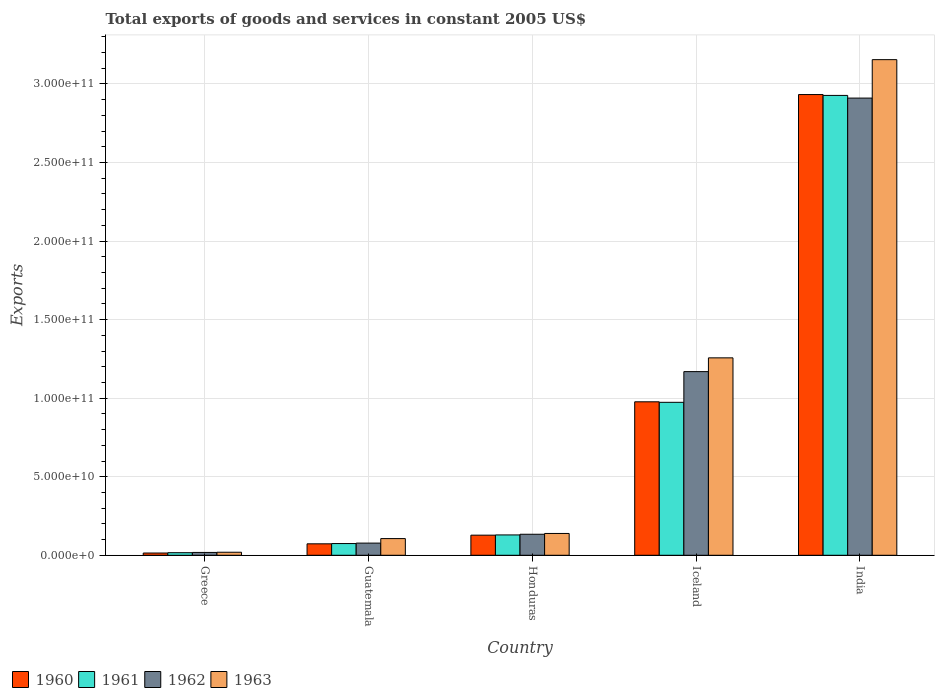How many different coloured bars are there?
Give a very brief answer. 4. Are the number of bars on each tick of the X-axis equal?
Provide a short and direct response. Yes. How many bars are there on the 1st tick from the left?
Offer a very short reply. 4. How many bars are there on the 4th tick from the right?
Keep it short and to the point. 4. What is the total exports of goods and services in 1960 in Greece?
Offer a terse response. 1.43e+09. Across all countries, what is the maximum total exports of goods and services in 1960?
Make the answer very short. 2.93e+11. Across all countries, what is the minimum total exports of goods and services in 1963?
Provide a short and direct response. 1.93e+09. In which country was the total exports of goods and services in 1962 maximum?
Make the answer very short. India. What is the total total exports of goods and services in 1960 in the graph?
Your response must be concise. 4.12e+11. What is the difference between the total exports of goods and services in 1961 in Guatemala and that in Honduras?
Your answer should be very brief. -5.49e+09. What is the difference between the total exports of goods and services in 1963 in Greece and the total exports of goods and services in 1960 in Honduras?
Offer a very short reply. -1.09e+1. What is the average total exports of goods and services in 1963 per country?
Keep it short and to the point. 9.35e+1. What is the difference between the total exports of goods and services of/in 1963 and total exports of goods and services of/in 1961 in Honduras?
Provide a short and direct response. 9.34e+08. In how many countries, is the total exports of goods and services in 1962 greater than 70000000000 US$?
Your response must be concise. 2. What is the ratio of the total exports of goods and services in 1961 in Honduras to that in Iceland?
Offer a very short reply. 0.13. Is the total exports of goods and services in 1961 in Greece less than that in India?
Your answer should be compact. Yes. Is the difference between the total exports of goods and services in 1963 in Greece and India greater than the difference between the total exports of goods and services in 1961 in Greece and India?
Keep it short and to the point. No. What is the difference between the highest and the second highest total exports of goods and services in 1961?
Offer a terse response. 2.80e+11. What is the difference between the highest and the lowest total exports of goods and services in 1961?
Make the answer very short. 2.91e+11. Is the sum of the total exports of goods and services in 1963 in Iceland and India greater than the maximum total exports of goods and services in 1962 across all countries?
Make the answer very short. Yes. Is it the case that in every country, the sum of the total exports of goods and services in 1961 and total exports of goods and services in 1963 is greater than the sum of total exports of goods and services in 1960 and total exports of goods and services in 1962?
Ensure brevity in your answer.  No. What does the 1st bar from the left in Iceland represents?
Provide a short and direct response. 1960. What does the 4th bar from the right in Guatemala represents?
Your answer should be very brief. 1960. Is it the case that in every country, the sum of the total exports of goods and services in 1963 and total exports of goods and services in 1960 is greater than the total exports of goods and services in 1961?
Your answer should be very brief. Yes. How many bars are there?
Keep it short and to the point. 20. How many countries are there in the graph?
Give a very brief answer. 5. Does the graph contain any zero values?
Make the answer very short. No. Where does the legend appear in the graph?
Provide a short and direct response. Bottom left. How many legend labels are there?
Offer a very short reply. 4. How are the legend labels stacked?
Provide a succinct answer. Horizontal. What is the title of the graph?
Provide a short and direct response. Total exports of goods and services in constant 2005 US$. Does "2013" appear as one of the legend labels in the graph?
Your answer should be very brief. No. What is the label or title of the X-axis?
Make the answer very short. Country. What is the label or title of the Y-axis?
Keep it short and to the point. Exports. What is the Exports of 1960 in Greece?
Offer a very short reply. 1.43e+09. What is the Exports in 1961 in Greece?
Your answer should be very brief. 1.64e+09. What is the Exports of 1962 in Greece?
Your answer should be compact. 1.81e+09. What is the Exports in 1963 in Greece?
Provide a short and direct response. 1.93e+09. What is the Exports of 1960 in Guatemala?
Make the answer very short. 7.29e+09. What is the Exports in 1961 in Guatemala?
Keep it short and to the point. 7.46e+09. What is the Exports in 1962 in Guatemala?
Provide a short and direct response. 7.75e+09. What is the Exports in 1963 in Guatemala?
Ensure brevity in your answer.  1.06e+1. What is the Exports in 1960 in Honduras?
Keep it short and to the point. 1.28e+1. What is the Exports in 1961 in Honduras?
Offer a terse response. 1.30e+1. What is the Exports of 1962 in Honduras?
Your answer should be compact. 1.34e+1. What is the Exports of 1963 in Honduras?
Ensure brevity in your answer.  1.39e+1. What is the Exports of 1960 in Iceland?
Give a very brief answer. 9.77e+1. What is the Exports in 1961 in Iceland?
Offer a terse response. 9.74e+1. What is the Exports in 1962 in Iceland?
Provide a short and direct response. 1.17e+11. What is the Exports in 1963 in Iceland?
Give a very brief answer. 1.26e+11. What is the Exports of 1960 in India?
Ensure brevity in your answer.  2.93e+11. What is the Exports in 1961 in India?
Offer a very short reply. 2.93e+11. What is the Exports in 1962 in India?
Your answer should be compact. 2.91e+11. What is the Exports in 1963 in India?
Keep it short and to the point. 3.15e+11. Across all countries, what is the maximum Exports of 1960?
Make the answer very short. 2.93e+11. Across all countries, what is the maximum Exports in 1961?
Ensure brevity in your answer.  2.93e+11. Across all countries, what is the maximum Exports in 1962?
Keep it short and to the point. 2.91e+11. Across all countries, what is the maximum Exports in 1963?
Your answer should be very brief. 3.15e+11. Across all countries, what is the minimum Exports in 1960?
Your answer should be very brief. 1.43e+09. Across all countries, what is the minimum Exports of 1961?
Offer a very short reply. 1.64e+09. Across all countries, what is the minimum Exports in 1962?
Give a very brief answer. 1.81e+09. Across all countries, what is the minimum Exports of 1963?
Offer a very short reply. 1.93e+09. What is the total Exports of 1960 in the graph?
Your answer should be compact. 4.12e+11. What is the total Exports in 1961 in the graph?
Ensure brevity in your answer.  4.12e+11. What is the total Exports of 1962 in the graph?
Provide a short and direct response. 4.31e+11. What is the total Exports in 1963 in the graph?
Give a very brief answer. 4.68e+11. What is the difference between the Exports in 1960 in Greece and that in Guatemala?
Your response must be concise. -5.85e+09. What is the difference between the Exports in 1961 in Greece and that in Guatemala?
Your answer should be very brief. -5.82e+09. What is the difference between the Exports in 1962 in Greece and that in Guatemala?
Provide a succinct answer. -5.94e+09. What is the difference between the Exports of 1963 in Greece and that in Guatemala?
Give a very brief answer. -8.70e+09. What is the difference between the Exports of 1960 in Greece and that in Honduras?
Provide a short and direct response. -1.14e+1. What is the difference between the Exports in 1961 in Greece and that in Honduras?
Offer a very short reply. -1.13e+1. What is the difference between the Exports in 1962 in Greece and that in Honduras?
Ensure brevity in your answer.  -1.16e+1. What is the difference between the Exports of 1963 in Greece and that in Honduras?
Your answer should be compact. -1.20e+1. What is the difference between the Exports in 1960 in Greece and that in Iceland?
Offer a very short reply. -9.63e+1. What is the difference between the Exports in 1961 in Greece and that in Iceland?
Your answer should be compact. -9.57e+1. What is the difference between the Exports of 1962 in Greece and that in Iceland?
Provide a short and direct response. -1.15e+11. What is the difference between the Exports in 1963 in Greece and that in Iceland?
Offer a terse response. -1.24e+11. What is the difference between the Exports of 1960 in Greece and that in India?
Keep it short and to the point. -2.92e+11. What is the difference between the Exports in 1961 in Greece and that in India?
Provide a succinct answer. -2.91e+11. What is the difference between the Exports in 1962 in Greece and that in India?
Give a very brief answer. -2.89e+11. What is the difference between the Exports of 1963 in Greece and that in India?
Provide a short and direct response. -3.14e+11. What is the difference between the Exports of 1960 in Guatemala and that in Honduras?
Provide a short and direct response. -5.51e+09. What is the difference between the Exports of 1961 in Guatemala and that in Honduras?
Your answer should be very brief. -5.49e+09. What is the difference between the Exports in 1962 in Guatemala and that in Honduras?
Your answer should be compact. -5.63e+09. What is the difference between the Exports in 1963 in Guatemala and that in Honduras?
Your answer should be compact. -3.26e+09. What is the difference between the Exports of 1960 in Guatemala and that in Iceland?
Your answer should be very brief. -9.04e+1. What is the difference between the Exports of 1961 in Guatemala and that in Iceland?
Offer a very short reply. -8.99e+1. What is the difference between the Exports in 1962 in Guatemala and that in Iceland?
Your answer should be very brief. -1.09e+11. What is the difference between the Exports of 1963 in Guatemala and that in Iceland?
Your answer should be compact. -1.15e+11. What is the difference between the Exports of 1960 in Guatemala and that in India?
Provide a succinct answer. -2.86e+11. What is the difference between the Exports of 1961 in Guatemala and that in India?
Provide a short and direct response. -2.85e+11. What is the difference between the Exports in 1962 in Guatemala and that in India?
Provide a short and direct response. -2.83e+11. What is the difference between the Exports of 1963 in Guatemala and that in India?
Provide a succinct answer. -3.05e+11. What is the difference between the Exports of 1960 in Honduras and that in Iceland?
Provide a short and direct response. -8.49e+1. What is the difference between the Exports in 1961 in Honduras and that in Iceland?
Make the answer very short. -8.44e+1. What is the difference between the Exports of 1962 in Honduras and that in Iceland?
Provide a succinct answer. -1.04e+11. What is the difference between the Exports in 1963 in Honduras and that in Iceland?
Your answer should be compact. -1.12e+11. What is the difference between the Exports in 1960 in Honduras and that in India?
Your response must be concise. -2.80e+11. What is the difference between the Exports of 1961 in Honduras and that in India?
Provide a succinct answer. -2.80e+11. What is the difference between the Exports of 1962 in Honduras and that in India?
Make the answer very short. -2.78e+11. What is the difference between the Exports of 1963 in Honduras and that in India?
Provide a succinct answer. -3.02e+11. What is the difference between the Exports of 1960 in Iceland and that in India?
Offer a terse response. -1.96e+11. What is the difference between the Exports in 1961 in Iceland and that in India?
Your answer should be compact. -1.95e+11. What is the difference between the Exports in 1962 in Iceland and that in India?
Provide a succinct answer. -1.74e+11. What is the difference between the Exports of 1963 in Iceland and that in India?
Your answer should be very brief. -1.90e+11. What is the difference between the Exports in 1960 in Greece and the Exports in 1961 in Guatemala?
Provide a succinct answer. -6.02e+09. What is the difference between the Exports of 1960 in Greece and the Exports of 1962 in Guatemala?
Make the answer very short. -6.31e+09. What is the difference between the Exports in 1960 in Greece and the Exports in 1963 in Guatemala?
Make the answer very short. -9.19e+09. What is the difference between the Exports of 1961 in Greece and the Exports of 1962 in Guatemala?
Your answer should be compact. -6.10e+09. What is the difference between the Exports of 1961 in Greece and the Exports of 1963 in Guatemala?
Your answer should be compact. -8.98e+09. What is the difference between the Exports of 1962 in Greece and the Exports of 1963 in Guatemala?
Your answer should be very brief. -8.82e+09. What is the difference between the Exports of 1960 in Greece and the Exports of 1961 in Honduras?
Your answer should be compact. -1.15e+1. What is the difference between the Exports in 1960 in Greece and the Exports in 1962 in Honduras?
Your response must be concise. -1.19e+1. What is the difference between the Exports in 1960 in Greece and the Exports in 1963 in Honduras?
Ensure brevity in your answer.  -1.25e+1. What is the difference between the Exports of 1961 in Greece and the Exports of 1962 in Honduras?
Provide a succinct answer. -1.17e+1. What is the difference between the Exports in 1961 in Greece and the Exports in 1963 in Honduras?
Offer a terse response. -1.22e+1. What is the difference between the Exports in 1962 in Greece and the Exports in 1963 in Honduras?
Offer a terse response. -1.21e+1. What is the difference between the Exports of 1960 in Greece and the Exports of 1961 in Iceland?
Give a very brief answer. -9.59e+1. What is the difference between the Exports of 1960 in Greece and the Exports of 1962 in Iceland?
Your response must be concise. -1.15e+11. What is the difference between the Exports in 1960 in Greece and the Exports in 1963 in Iceland?
Your answer should be very brief. -1.24e+11. What is the difference between the Exports in 1961 in Greece and the Exports in 1962 in Iceland?
Make the answer very short. -1.15e+11. What is the difference between the Exports in 1961 in Greece and the Exports in 1963 in Iceland?
Make the answer very short. -1.24e+11. What is the difference between the Exports in 1962 in Greece and the Exports in 1963 in Iceland?
Provide a succinct answer. -1.24e+11. What is the difference between the Exports in 1960 in Greece and the Exports in 1961 in India?
Offer a terse response. -2.91e+11. What is the difference between the Exports in 1960 in Greece and the Exports in 1962 in India?
Keep it short and to the point. -2.90e+11. What is the difference between the Exports in 1960 in Greece and the Exports in 1963 in India?
Your answer should be very brief. -3.14e+11. What is the difference between the Exports of 1961 in Greece and the Exports of 1962 in India?
Make the answer very short. -2.89e+11. What is the difference between the Exports of 1961 in Greece and the Exports of 1963 in India?
Your response must be concise. -3.14e+11. What is the difference between the Exports in 1962 in Greece and the Exports in 1963 in India?
Your response must be concise. -3.14e+11. What is the difference between the Exports of 1960 in Guatemala and the Exports of 1961 in Honduras?
Offer a very short reply. -5.66e+09. What is the difference between the Exports in 1960 in Guatemala and the Exports in 1962 in Honduras?
Give a very brief answer. -6.09e+09. What is the difference between the Exports in 1960 in Guatemala and the Exports in 1963 in Honduras?
Keep it short and to the point. -6.60e+09. What is the difference between the Exports in 1961 in Guatemala and the Exports in 1962 in Honduras?
Offer a very short reply. -5.92e+09. What is the difference between the Exports of 1961 in Guatemala and the Exports of 1963 in Honduras?
Provide a short and direct response. -6.43e+09. What is the difference between the Exports in 1962 in Guatemala and the Exports in 1963 in Honduras?
Your answer should be very brief. -6.14e+09. What is the difference between the Exports in 1960 in Guatemala and the Exports in 1961 in Iceland?
Give a very brief answer. -9.01e+1. What is the difference between the Exports in 1960 in Guatemala and the Exports in 1962 in Iceland?
Give a very brief answer. -1.10e+11. What is the difference between the Exports in 1960 in Guatemala and the Exports in 1963 in Iceland?
Give a very brief answer. -1.18e+11. What is the difference between the Exports of 1961 in Guatemala and the Exports of 1962 in Iceland?
Offer a very short reply. -1.09e+11. What is the difference between the Exports in 1961 in Guatemala and the Exports in 1963 in Iceland?
Your response must be concise. -1.18e+11. What is the difference between the Exports in 1962 in Guatemala and the Exports in 1963 in Iceland?
Your response must be concise. -1.18e+11. What is the difference between the Exports of 1960 in Guatemala and the Exports of 1961 in India?
Your answer should be compact. -2.85e+11. What is the difference between the Exports of 1960 in Guatemala and the Exports of 1962 in India?
Ensure brevity in your answer.  -2.84e+11. What is the difference between the Exports of 1960 in Guatemala and the Exports of 1963 in India?
Your response must be concise. -3.08e+11. What is the difference between the Exports in 1961 in Guatemala and the Exports in 1962 in India?
Your response must be concise. -2.84e+11. What is the difference between the Exports of 1961 in Guatemala and the Exports of 1963 in India?
Offer a terse response. -3.08e+11. What is the difference between the Exports of 1962 in Guatemala and the Exports of 1963 in India?
Ensure brevity in your answer.  -3.08e+11. What is the difference between the Exports in 1960 in Honduras and the Exports in 1961 in Iceland?
Make the answer very short. -8.46e+1. What is the difference between the Exports of 1960 in Honduras and the Exports of 1962 in Iceland?
Keep it short and to the point. -1.04e+11. What is the difference between the Exports of 1960 in Honduras and the Exports of 1963 in Iceland?
Ensure brevity in your answer.  -1.13e+11. What is the difference between the Exports of 1961 in Honduras and the Exports of 1962 in Iceland?
Make the answer very short. -1.04e+11. What is the difference between the Exports of 1961 in Honduras and the Exports of 1963 in Iceland?
Offer a very short reply. -1.13e+11. What is the difference between the Exports in 1962 in Honduras and the Exports in 1963 in Iceland?
Ensure brevity in your answer.  -1.12e+11. What is the difference between the Exports in 1960 in Honduras and the Exports in 1961 in India?
Provide a short and direct response. -2.80e+11. What is the difference between the Exports of 1960 in Honduras and the Exports of 1962 in India?
Ensure brevity in your answer.  -2.78e+11. What is the difference between the Exports of 1960 in Honduras and the Exports of 1963 in India?
Your answer should be very brief. -3.03e+11. What is the difference between the Exports of 1961 in Honduras and the Exports of 1962 in India?
Keep it short and to the point. -2.78e+11. What is the difference between the Exports in 1961 in Honduras and the Exports in 1963 in India?
Make the answer very short. -3.03e+11. What is the difference between the Exports of 1962 in Honduras and the Exports of 1963 in India?
Offer a terse response. -3.02e+11. What is the difference between the Exports of 1960 in Iceland and the Exports of 1961 in India?
Offer a terse response. -1.95e+11. What is the difference between the Exports in 1960 in Iceland and the Exports in 1962 in India?
Make the answer very short. -1.93e+11. What is the difference between the Exports in 1960 in Iceland and the Exports in 1963 in India?
Make the answer very short. -2.18e+11. What is the difference between the Exports in 1961 in Iceland and the Exports in 1962 in India?
Your response must be concise. -1.94e+11. What is the difference between the Exports in 1961 in Iceland and the Exports in 1963 in India?
Ensure brevity in your answer.  -2.18e+11. What is the difference between the Exports of 1962 in Iceland and the Exports of 1963 in India?
Provide a succinct answer. -1.99e+11. What is the average Exports in 1960 per country?
Your response must be concise. 8.25e+1. What is the average Exports of 1961 per country?
Give a very brief answer. 8.24e+1. What is the average Exports in 1962 per country?
Offer a very short reply. 8.62e+1. What is the average Exports of 1963 per country?
Ensure brevity in your answer.  9.35e+1. What is the difference between the Exports in 1960 and Exports in 1961 in Greece?
Ensure brevity in your answer.  -2.08e+08. What is the difference between the Exports of 1960 and Exports of 1962 in Greece?
Offer a very short reply. -3.72e+08. What is the difference between the Exports in 1960 and Exports in 1963 in Greece?
Provide a succinct answer. -4.92e+08. What is the difference between the Exports in 1961 and Exports in 1962 in Greece?
Your answer should be very brief. -1.64e+08. What is the difference between the Exports of 1961 and Exports of 1963 in Greece?
Your answer should be compact. -2.84e+08. What is the difference between the Exports of 1962 and Exports of 1963 in Greece?
Give a very brief answer. -1.20e+08. What is the difference between the Exports in 1960 and Exports in 1961 in Guatemala?
Your response must be concise. -1.71e+08. What is the difference between the Exports in 1960 and Exports in 1962 in Guatemala?
Your answer should be very brief. -4.57e+08. What is the difference between the Exports in 1960 and Exports in 1963 in Guatemala?
Give a very brief answer. -3.33e+09. What is the difference between the Exports of 1961 and Exports of 1962 in Guatemala?
Provide a succinct answer. -2.86e+08. What is the difference between the Exports of 1961 and Exports of 1963 in Guatemala?
Your response must be concise. -3.16e+09. What is the difference between the Exports of 1962 and Exports of 1963 in Guatemala?
Your answer should be compact. -2.88e+09. What is the difference between the Exports in 1960 and Exports in 1961 in Honduras?
Make the answer very short. -1.52e+08. What is the difference between the Exports of 1960 and Exports of 1962 in Honduras?
Keep it short and to the point. -5.74e+08. What is the difference between the Exports in 1960 and Exports in 1963 in Honduras?
Your answer should be very brief. -1.09e+09. What is the difference between the Exports in 1961 and Exports in 1962 in Honduras?
Make the answer very short. -4.22e+08. What is the difference between the Exports of 1961 and Exports of 1963 in Honduras?
Make the answer very short. -9.34e+08. What is the difference between the Exports of 1962 and Exports of 1963 in Honduras?
Your response must be concise. -5.12e+08. What is the difference between the Exports in 1960 and Exports in 1961 in Iceland?
Give a very brief answer. 3.34e+08. What is the difference between the Exports of 1960 and Exports of 1962 in Iceland?
Keep it short and to the point. -1.92e+1. What is the difference between the Exports of 1960 and Exports of 1963 in Iceland?
Provide a succinct answer. -2.80e+1. What is the difference between the Exports of 1961 and Exports of 1962 in Iceland?
Your answer should be very brief. -1.95e+1. What is the difference between the Exports of 1961 and Exports of 1963 in Iceland?
Provide a short and direct response. -2.83e+1. What is the difference between the Exports in 1962 and Exports in 1963 in Iceland?
Offer a very short reply. -8.76e+09. What is the difference between the Exports of 1960 and Exports of 1961 in India?
Your response must be concise. 5.45e+08. What is the difference between the Exports of 1960 and Exports of 1962 in India?
Provide a succinct answer. 2.24e+09. What is the difference between the Exports in 1960 and Exports in 1963 in India?
Provide a short and direct response. -2.22e+1. What is the difference between the Exports of 1961 and Exports of 1962 in India?
Your response must be concise. 1.70e+09. What is the difference between the Exports of 1961 and Exports of 1963 in India?
Your response must be concise. -2.28e+1. What is the difference between the Exports in 1962 and Exports in 1963 in India?
Provide a succinct answer. -2.45e+1. What is the ratio of the Exports in 1960 in Greece to that in Guatemala?
Keep it short and to the point. 0.2. What is the ratio of the Exports of 1961 in Greece to that in Guatemala?
Provide a short and direct response. 0.22. What is the ratio of the Exports of 1962 in Greece to that in Guatemala?
Your answer should be compact. 0.23. What is the ratio of the Exports in 1963 in Greece to that in Guatemala?
Your answer should be compact. 0.18. What is the ratio of the Exports in 1960 in Greece to that in Honduras?
Keep it short and to the point. 0.11. What is the ratio of the Exports of 1961 in Greece to that in Honduras?
Provide a short and direct response. 0.13. What is the ratio of the Exports in 1962 in Greece to that in Honduras?
Your answer should be compact. 0.14. What is the ratio of the Exports of 1963 in Greece to that in Honduras?
Provide a succinct answer. 0.14. What is the ratio of the Exports of 1960 in Greece to that in Iceland?
Provide a short and direct response. 0.01. What is the ratio of the Exports in 1961 in Greece to that in Iceland?
Your response must be concise. 0.02. What is the ratio of the Exports in 1962 in Greece to that in Iceland?
Keep it short and to the point. 0.02. What is the ratio of the Exports in 1963 in Greece to that in Iceland?
Make the answer very short. 0.02. What is the ratio of the Exports in 1960 in Greece to that in India?
Ensure brevity in your answer.  0. What is the ratio of the Exports of 1961 in Greece to that in India?
Make the answer very short. 0.01. What is the ratio of the Exports of 1962 in Greece to that in India?
Provide a succinct answer. 0.01. What is the ratio of the Exports in 1963 in Greece to that in India?
Your response must be concise. 0.01. What is the ratio of the Exports in 1960 in Guatemala to that in Honduras?
Keep it short and to the point. 0.57. What is the ratio of the Exports in 1961 in Guatemala to that in Honduras?
Your answer should be very brief. 0.58. What is the ratio of the Exports in 1962 in Guatemala to that in Honduras?
Your answer should be very brief. 0.58. What is the ratio of the Exports of 1963 in Guatemala to that in Honduras?
Provide a succinct answer. 0.76. What is the ratio of the Exports of 1960 in Guatemala to that in Iceland?
Provide a short and direct response. 0.07. What is the ratio of the Exports in 1961 in Guatemala to that in Iceland?
Offer a very short reply. 0.08. What is the ratio of the Exports in 1962 in Guatemala to that in Iceland?
Provide a short and direct response. 0.07. What is the ratio of the Exports in 1963 in Guatemala to that in Iceland?
Offer a very short reply. 0.08. What is the ratio of the Exports in 1960 in Guatemala to that in India?
Make the answer very short. 0.02. What is the ratio of the Exports in 1961 in Guatemala to that in India?
Your answer should be compact. 0.03. What is the ratio of the Exports of 1962 in Guatemala to that in India?
Offer a terse response. 0.03. What is the ratio of the Exports of 1963 in Guatemala to that in India?
Give a very brief answer. 0.03. What is the ratio of the Exports in 1960 in Honduras to that in Iceland?
Offer a terse response. 0.13. What is the ratio of the Exports of 1961 in Honduras to that in Iceland?
Ensure brevity in your answer.  0.13. What is the ratio of the Exports of 1962 in Honduras to that in Iceland?
Keep it short and to the point. 0.11. What is the ratio of the Exports of 1963 in Honduras to that in Iceland?
Provide a short and direct response. 0.11. What is the ratio of the Exports in 1960 in Honduras to that in India?
Provide a short and direct response. 0.04. What is the ratio of the Exports in 1961 in Honduras to that in India?
Make the answer very short. 0.04. What is the ratio of the Exports in 1962 in Honduras to that in India?
Keep it short and to the point. 0.05. What is the ratio of the Exports of 1963 in Honduras to that in India?
Make the answer very short. 0.04. What is the ratio of the Exports in 1960 in Iceland to that in India?
Offer a terse response. 0.33. What is the ratio of the Exports in 1961 in Iceland to that in India?
Offer a terse response. 0.33. What is the ratio of the Exports of 1962 in Iceland to that in India?
Give a very brief answer. 0.4. What is the ratio of the Exports in 1963 in Iceland to that in India?
Your answer should be very brief. 0.4. What is the difference between the highest and the second highest Exports of 1960?
Give a very brief answer. 1.96e+11. What is the difference between the highest and the second highest Exports in 1961?
Provide a succinct answer. 1.95e+11. What is the difference between the highest and the second highest Exports of 1962?
Provide a succinct answer. 1.74e+11. What is the difference between the highest and the second highest Exports in 1963?
Ensure brevity in your answer.  1.90e+11. What is the difference between the highest and the lowest Exports of 1960?
Your response must be concise. 2.92e+11. What is the difference between the highest and the lowest Exports in 1961?
Make the answer very short. 2.91e+11. What is the difference between the highest and the lowest Exports of 1962?
Provide a short and direct response. 2.89e+11. What is the difference between the highest and the lowest Exports of 1963?
Provide a short and direct response. 3.14e+11. 